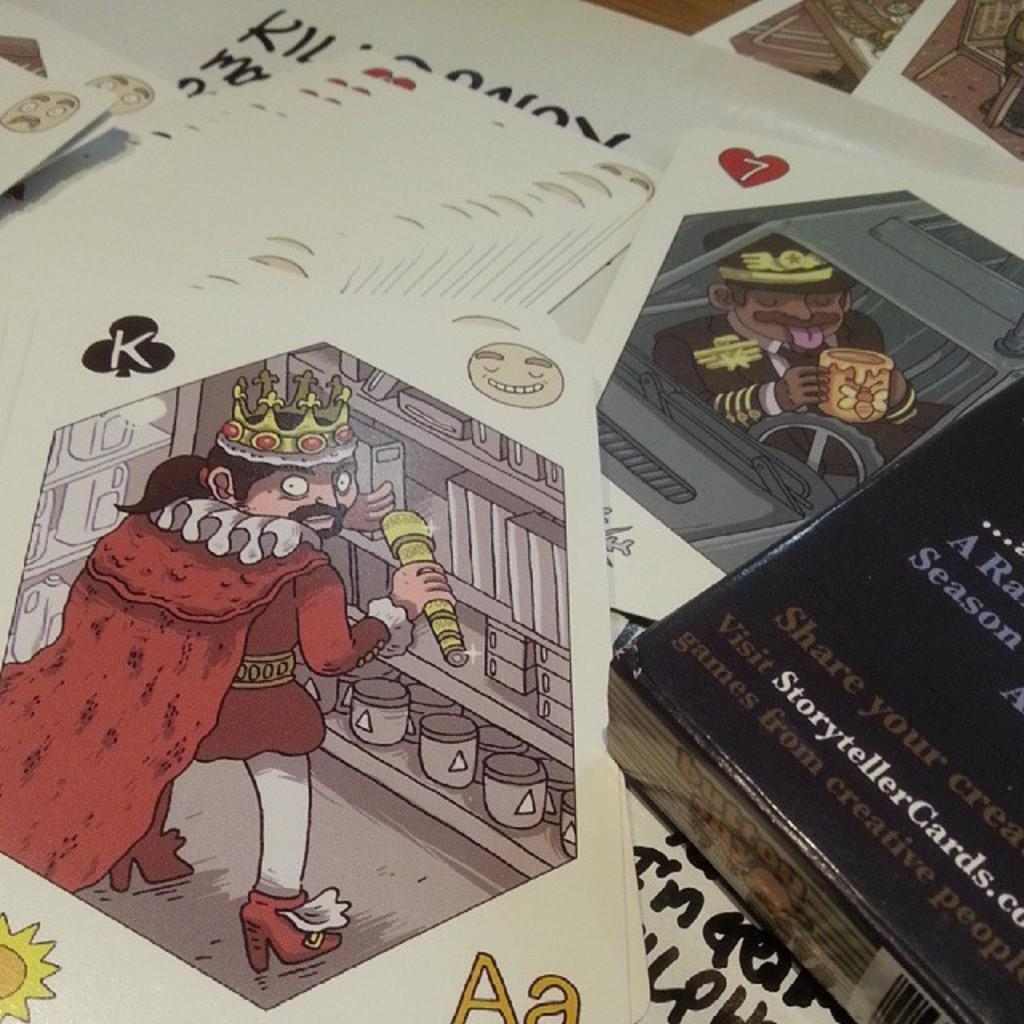<image>
Create a compact narrative representing the image presented. A pile of playing cards showing a King of Spades. 